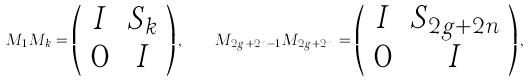<formula> <loc_0><loc_0><loc_500><loc_500>M _ { 1 } M _ { k } = \left ( \begin{array} { c c } I & S _ { k } \\ 0 & I \end{array} \right ) , \quad M _ { 2 g + 2 n - 1 } M _ { 2 g + 2 n } = \left ( \begin{array} { c c } I & S _ { 2 g + 2 n } \\ 0 & I \end{array} \right ) ,</formula> 